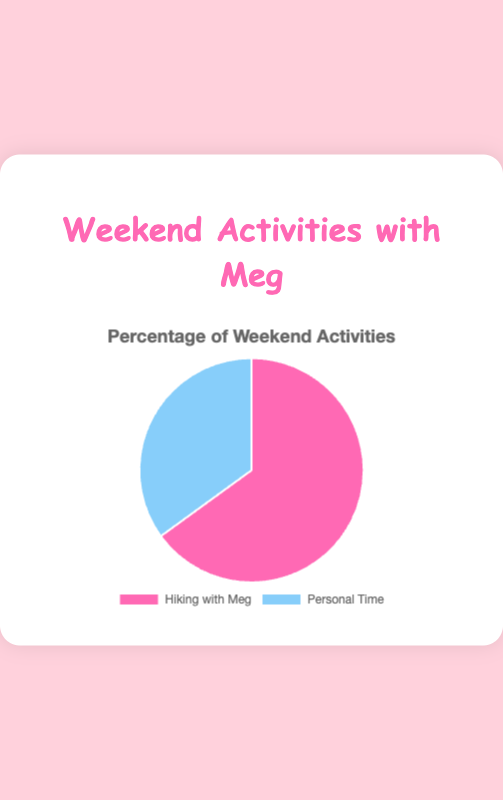What percentage of weekend activities is spent hiking with Meg? The pie chart shows two segments: 'Hiking with Meg' and 'Personal Time’. The 'Hiking with Meg' segment is labeled with 65%, which indicates that 65% of weekend activities are spent hiking with Meg.
Answer: 65% What is the ratio of time spent hiking with Meg to personal time? The pie chart indicates 65% of time is spent hiking with Meg and 35% for personal time. To find the ratio, divide 65 by 35, which simplifies to approximately 1.86.
Answer: 1.86 Which activity occupies the larger portion of the weekend? Observing the pie chart, the segment for 'Hiking with Meg' is visibly larger than 'Personal Time', and it is labeled with 65%, which is greater than 35%.
Answer: Hiking with Meg How much more time is spent hiking with Meg compared to personal time? The pie chart shows 65% of weekend time is hiking with Meg, and 35% is personal time. The difference is 65% - 35% = 30%.
Answer: 30% What are the activities mentioned in the chart? The pie chart has two labeled sections: 'Hiking with Meg' and 'Personal Time'.
Answer: Hiking with Meg and Personal Time What fraction of weekend activities is spent on personal time? The pie chart shows that 'Personal Time' occupies 35% of the weekend activities. To convert this percentage to a fraction, 35% can be expressed as 35/100, which simplifies to 7/20.
Answer: 7/20 If the total time for weekend activities is 20 hours, how many hours are spent on personal time? Given that 35% of the weekend activities are personal time, if the total time is 20 hours, then personal time = 0.35 * 20 hours = 7 hours.
Answer: 7 hours Which activity has a segment colored in pink? From the visual attributes of the pie chart, 'Hiking with Meg' is represented by the color pink.
Answer: Hiking with Meg Is the segment for 'Personal Time' less than half of the entire pie chart? The pie chart shows 'Personal Time' at 35%, which is less than 50%, indicating it is less than half of the chart.
Answer: Yes What's the average percentage for the weekend activities shown? The pie chart gives two percentages: 65% for 'Hiking with Meg' and 35% for 'Personal Time'. The average is calculated as (65+35)/2 = 100/2 = 50%.
Answer: 50% 